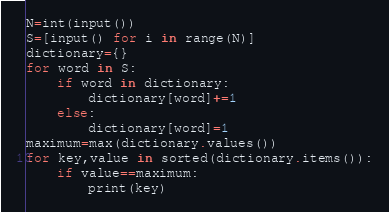<code> <loc_0><loc_0><loc_500><loc_500><_Python_>N=int(input())
S=[input() for i in range(N)]
dictionary={}
for word in S:
    if word in dictionary:
        dictionary[word]+=1
    else:
        dictionary[word]=1
maximum=max(dictionary.values())
for key,value in sorted(dictionary.items()):
    if value==maximum:
        print(key)</code> 